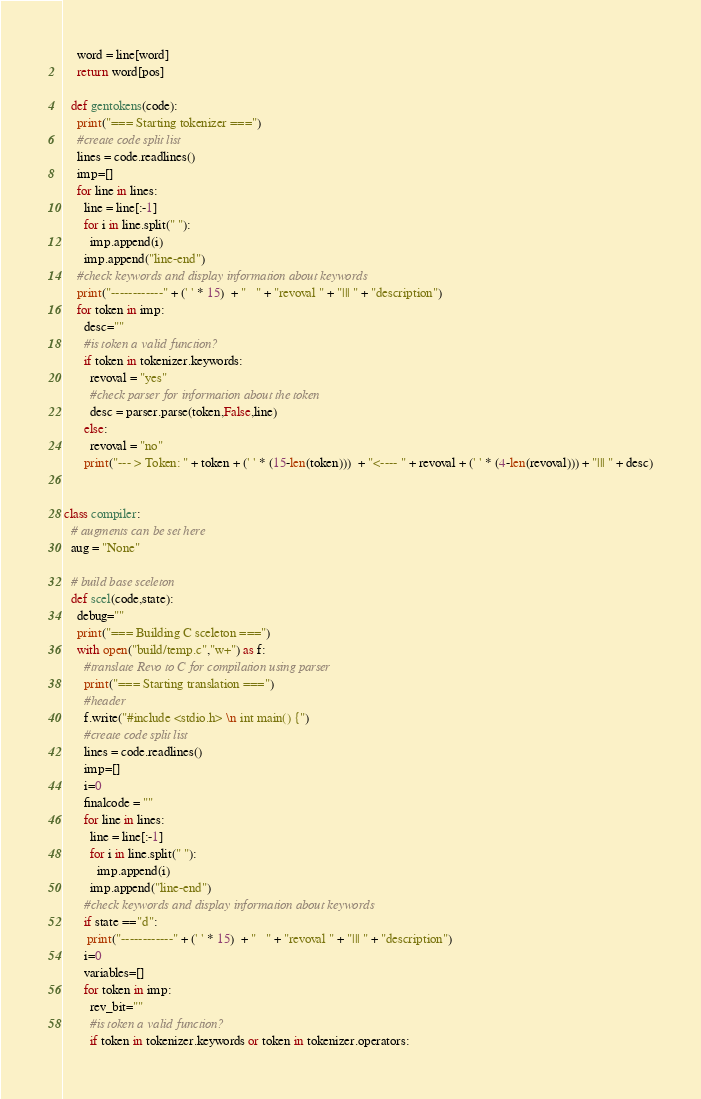Convert code to text. <code><loc_0><loc_0><loc_500><loc_500><_Python_>    word = line[word]
    return word[pos]

  def gentokens(code):
    print("=== Starting tokenizer ===")
    #create code split list
    lines = code.readlines()
    imp=[]
    for line in lines:
      line = line[:-1]
      for i in line.split(" "):
        imp.append(i)
      imp.append("line-end")
    #check keywords and display information about keywords
    print("------------" + (' ' * 15)  + "   " + "revoval " + "||| " + "description")
    for token in imp:
      desc=""
      #is token a valid function?
      if token in tokenizer.keywords:
        revoval = "yes"
        #check parser for information about the token
        desc = parser.parse(token,False,line)
      else:
        revoval = "no"
      print("--- > Token: " + token + (' ' * (15-len(token)))  + "<---- " + revoval + (' ' * (4-len(revoval))) + "||| " + desc)


class compiler:
  # augments can be set here
  aug = "None"

  # build base sceleton 
  def scel(code,state):
    debug=""
    print("=== Building C sceleton ===")
    with open("build/temp.c","w+") as f:
      #translate Revo to C for compilation using parser
      print("=== Starting translation ===")
      #header
      f.write("#include <stdio.h> \n int main() {")
      #create code split list
      lines = code.readlines()
      imp=[]
      i=0
      finalcode = ""
      for line in lines:
        line = line[:-1]
        for i in line.split(" "):
          imp.append(i)
        imp.append("line-end")
      #check keywords and display information about keywords
      if state =="d":
       print("------------" + (' ' * 15)  + "   " + "revoval " + "||| " + "description")
      i=0
      variables=[]
      for token in imp:
        rev_bit=""
        #is token a valid function?
        if token in tokenizer.keywords or token in tokenizer.operators:</code> 